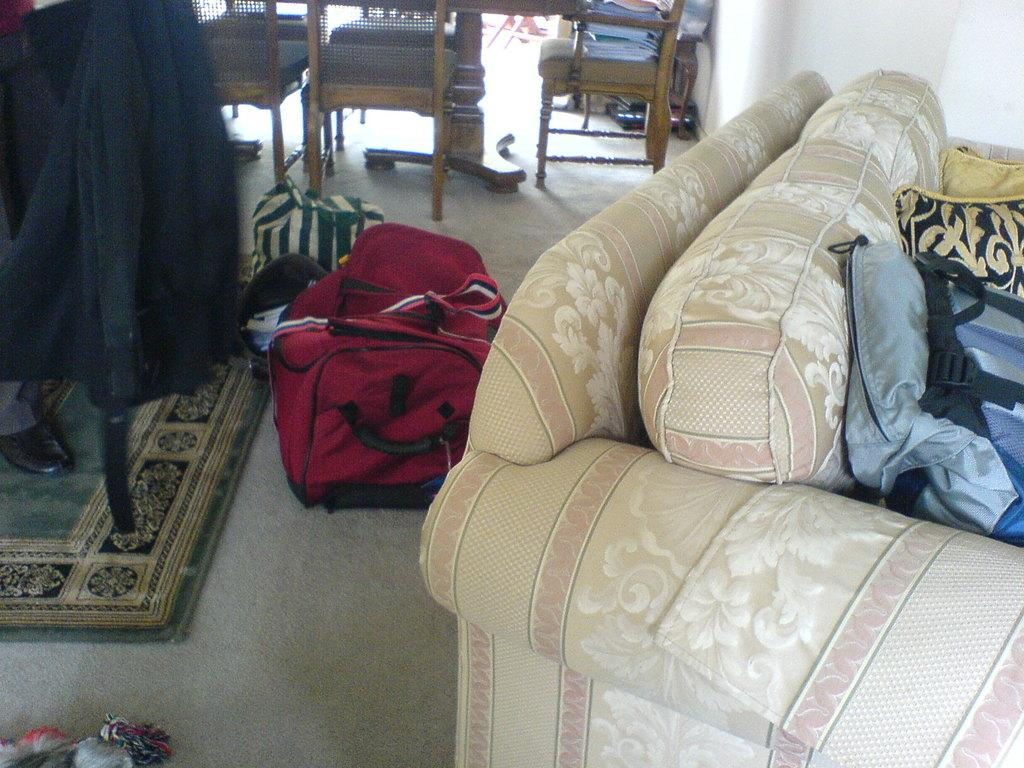Where is the image taken? The image is taken in a room. What is on the floor in the room? There is a mat, chairs, and bags on the floor. What type of furniture is in the room? There are chairs and a sofa in the room. What is behind the sofa? There is a wall behind the sofa. How many horses are visible in the image? There are no horses present in the image. What action are the bags performing in the image? The bags are not performing any action; they are stationary on the floor. 